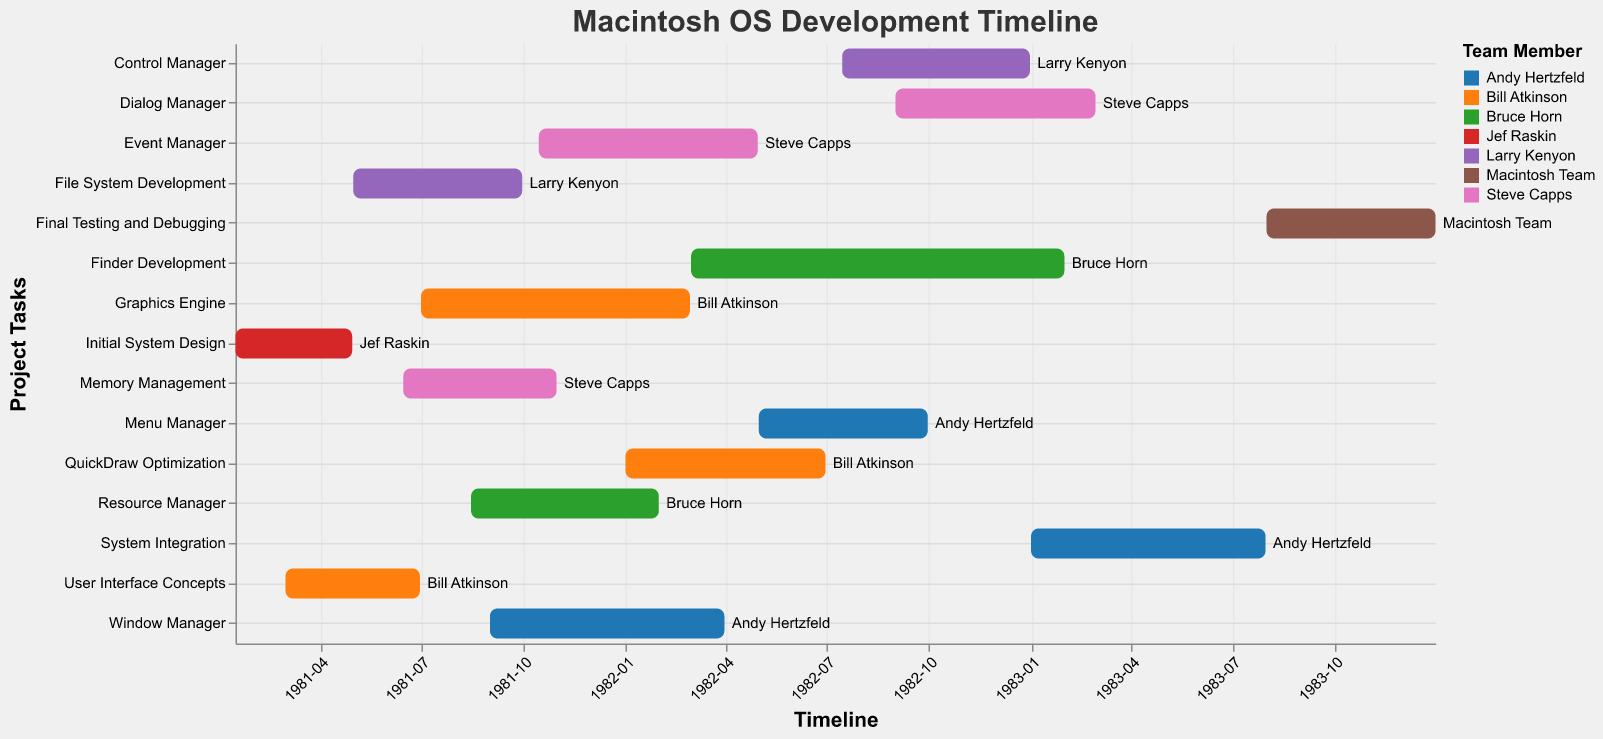What is the title of the Gantt Chart? The title of the Gantt Chart is displayed at the top of the chart in a bold font. Look for the text that is prominently displayed in the title section.
Answer: Macintosh OS Development Timeline Which team member is assigned to the Event Manager task? Look for the Event Manager task in the y-axis labels and check the corresponding name in the box or beside it.
Answer: Steve Capps How long did Bruce Horn work on Finder Development? Identify the start and end dates for Finder Development, then calculate the difference between these two dates. The start date is 1982-03-01, and the end date is 1983-01-31. The difference is 11 months.
Answer: 11 months Which task began first: the QuickDraw Optimization or the Control Manager? Compare the start dates of QuickDraw Optimization (1982-01-01) and Control Manager (1982-07-15). The task with the earlier start date began first.
Answer: QuickDraw Optimization How many tasks was Bill Atkinson assigned to? Count the number of distinct tasks assigned to Bill Atkinson by looking at all occurrences of his name in the chart.
Answer: 3 Which tasks did Andy Hertzfeld work on, and in what order? Look for all tasks that are assigned to Andy Hertzfeld and list them in the order of their start dates. He worked on Window Manager (1981-09-01), Menu Manager (1982-05-01), and System Integration (1983-01-01).
Answer: Window Manager, Menu Manager, System Integration What is the overall duration for the System Integration task? Identify the start and end dates for the System Integration task and calculate the duration. The start date is 1983-01-01, and the end date is 1983-07-31. The duration is 7 months.
Answer: 7 months Which task had the longest duration, and how long was it? Check the duration of each task by calculating the difference between their start and end dates. The task with the longest duration is Graphics Engine, lasting from 1981-07-01 to 1982-02-28, which is 8 months.
Answer: Graphics Engine, 8 months Were there any overlapping tasks for Steve Capps? If so, which ones? Locate all tasks assigned to Steve Capps and check their start and end dates to see if they overlap. Memory Management and Event Manager overlap from 1981-10-15 to 1981-10-31.
Answer: Memory Management and Event Manager What was the final task in the Macintosh OS development timeline? Look for the task that has the last end date in the entire chart. The final task is Final Testing and Debugging, which ends on 1983-12-31.
Answer: Final Testing and Debugging 